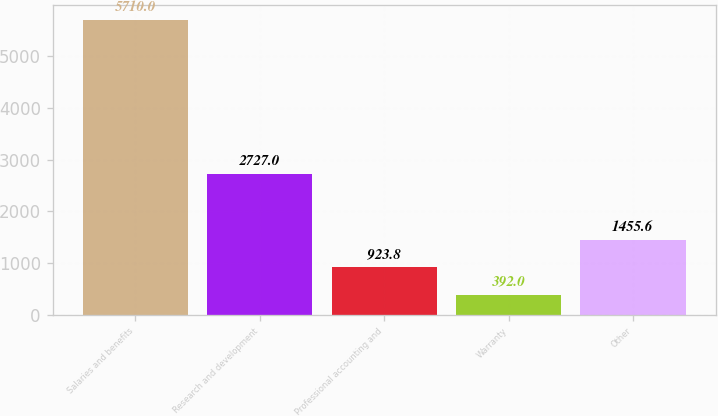<chart> <loc_0><loc_0><loc_500><loc_500><bar_chart><fcel>Salaries and benefits<fcel>Research and development<fcel>Professional accounting and<fcel>Warranty<fcel>Other<nl><fcel>5710<fcel>2727<fcel>923.8<fcel>392<fcel>1455.6<nl></chart> 